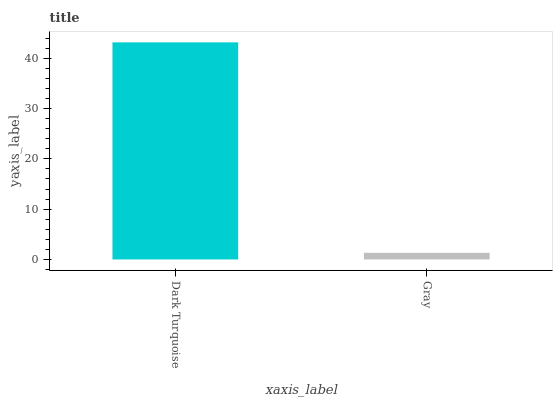Is Gray the minimum?
Answer yes or no. Yes. Is Dark Turquoise the maximum?
Answer yes or no. Yes. Is Gray the maximum?
Answer yes or no. No. Is Dark Turquoise greater than Gray?
Answer yes or no. Yes. Is Gray less than Dark Turquoise?
Answer yes or no. Yes. Is Gray greater than Dark Turquoise?
Answer yes or no. No. Is Dark Turquoise less than Gray?
Answer yes or no. No. Is Dark Turquoise the high median?
Answer yes or no. Yes. Is Gray the low median?
Answer yes or no. Yes. Is Gray the high median?
Answer yes or no. No. Is Dark Turquoise the low median?
Answer yes or no. No. 